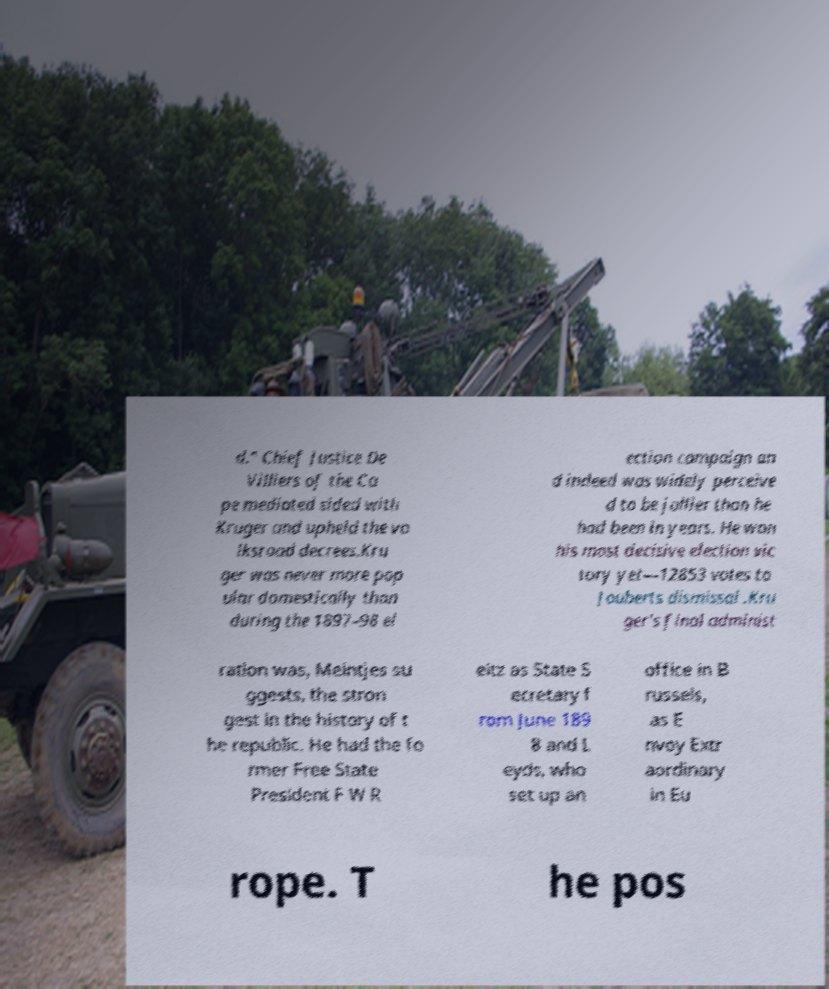Could you extract and type out the text from this image? d." Chief Justice De Villiers of the Ca pe mediated sided with Kruger and upheld the vo lksraad decrees.Kru ger was never more pop ular domestically than during the 1897–98 el ection campaign an d indeed was widely perceive d to be jollier than he had been in years. He won his most decisive election vic tory yet—12853 votes to Jouberts dismissal .Kru ger's final administ ration was, Meintjes su ggests, the stron gest in the history of t he republic. He had the fo rmer Free State President F W R eitz as State S ecretary f rom June 189 8 and L eyds, who set up an office in B russels, as E nvoy Extr aordinary in Eu rope. T he pos 